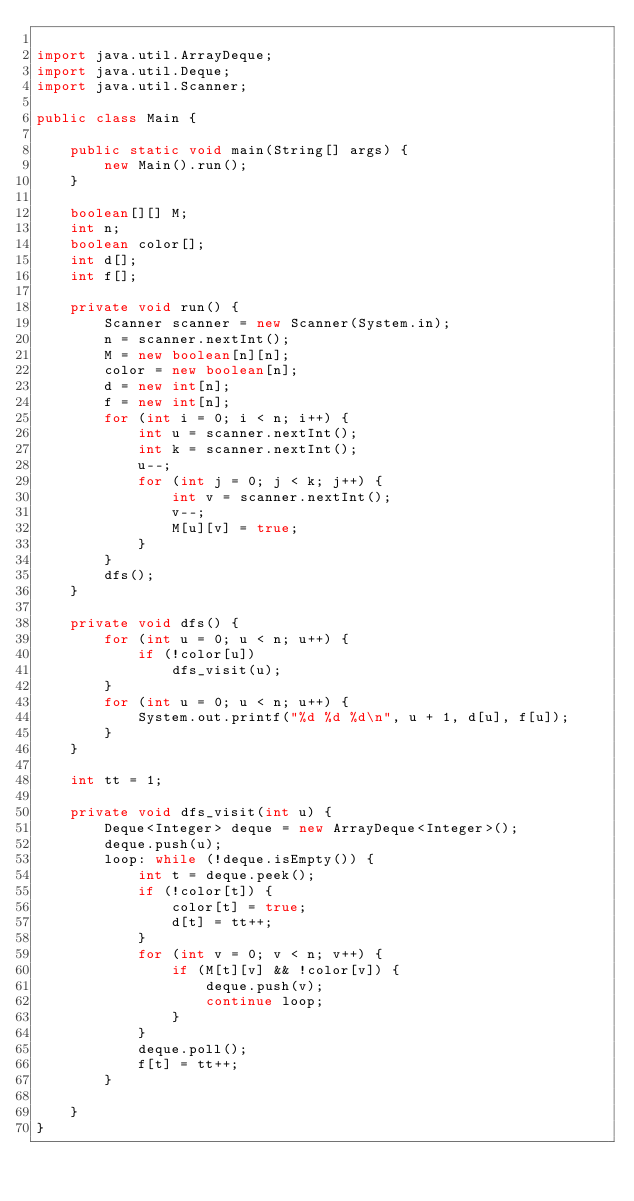Convert code to text. <code><loc_0><loc_0><loc_500><loc_500><_Java_>
import java.util.ArrayDeque;
import java.util.Deque;
import java.util.Scanner;

public class Main {

	public static void main(String[] args) {
		new Main().run();
	}

	boolean[][] M;
	int n;
	boolean color[];
	int d[];
	int f[];

	private void run() {
		Scanner scanner = new Scanner(System.in);
		n = scanner.nextInt();
		M = new boolean[n][n];
		color = new boolean[n];
		d = new int[n];
		f = new int[n];
		for (int i = 0; i < n; i++) {
			int u = scanner.nextInt();
			int k = scanner.nextInt();
			u--;
			for (int j = 0; j < k; j++) {
				int v = scanner.nextInt();
				v--;
				M[u][v] = true;
			}
		}
		dfs();
	}

	private void dfs() {
		for (int u = 0; u < n; u++) {
			if (!color[u])
				dfs_visit(u);
		}
		for (int u = 0; u < n; u++) {
			System.out.printf("%d %d %d\n", u + 1, d[u], f[u]);
		}
	}

	int tt = 1;

	private void dfs_visit(int u) {
		Deque<Integer> deque = new ArrayDeque<Integer>();
		deque.push(u);
		loop: while (!deque.isEmpty()) {
			int t = deque.peek();
			if (!color[t]) {
				color[t] = true;
				d[t] = tt++;
			}
			for (int v = 0; v < n; v++) {
				if (M[t][v] && !color[v]) {
					deque.push(v);
					continue loop;
				}
			}
			deque.poll();
			f[t] = tt++;
		}

	}
}</code> 